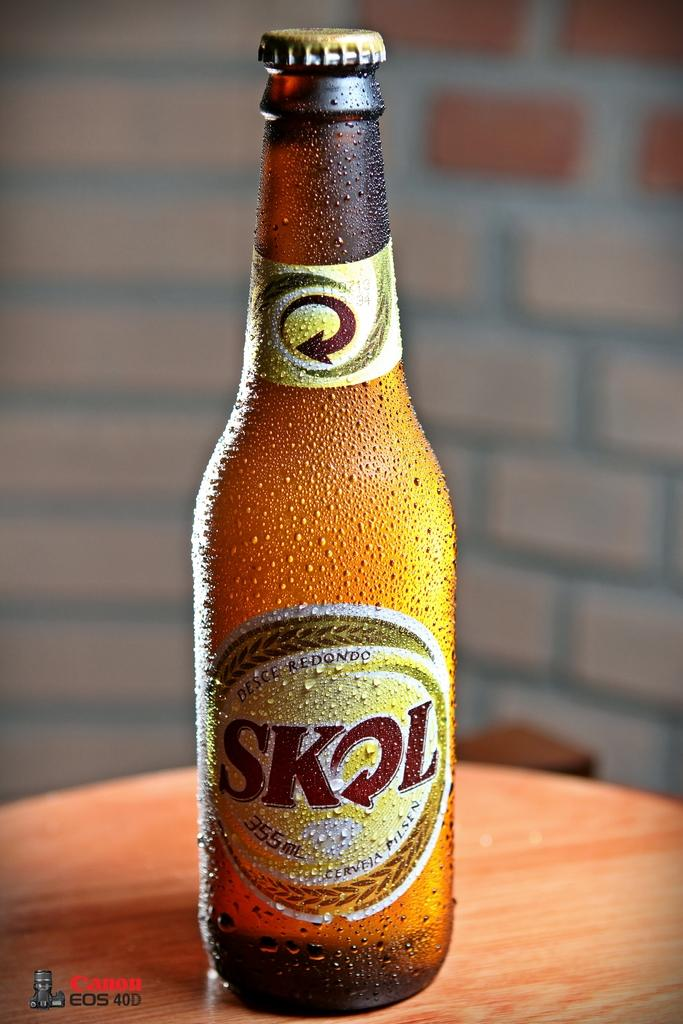<image>
Present a compact description of the photo's key features. A bottle of Skol looks frosty cold and is covered with moisture condensation. 